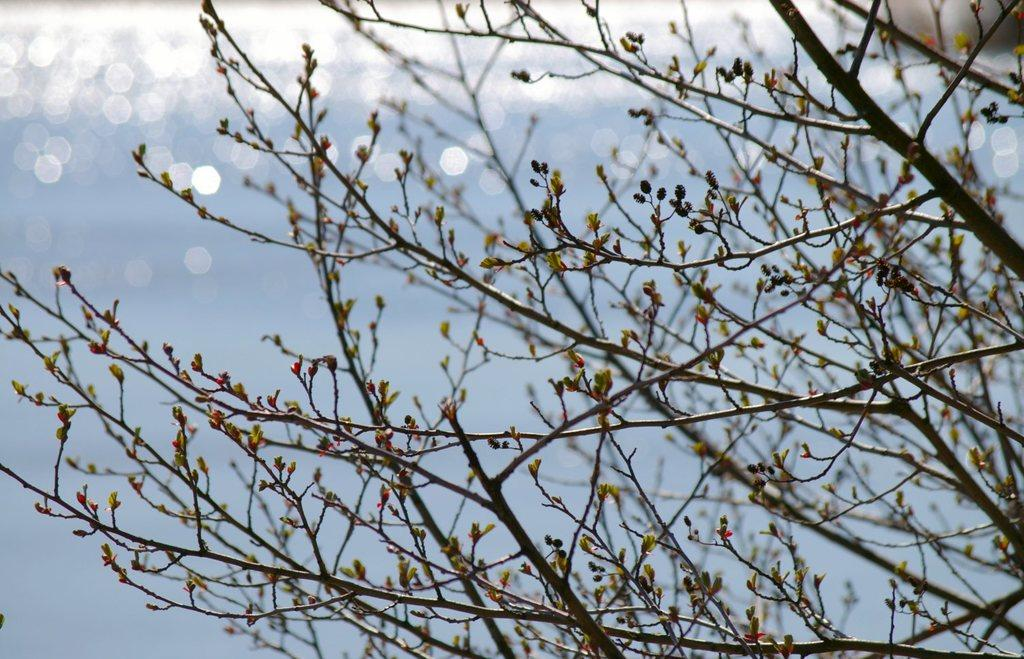What type of plant can be seen in the image? There is a tree in the image. What part of the natural environment is visible in the image? The sky is visible at the back side of the image. What type of wool can be seen in the image? There is no wool present in the image. How does the tree affect the acoustics in the image? The image does not provide information about the acoustics, so it cannot be determined how the tree affects them. 